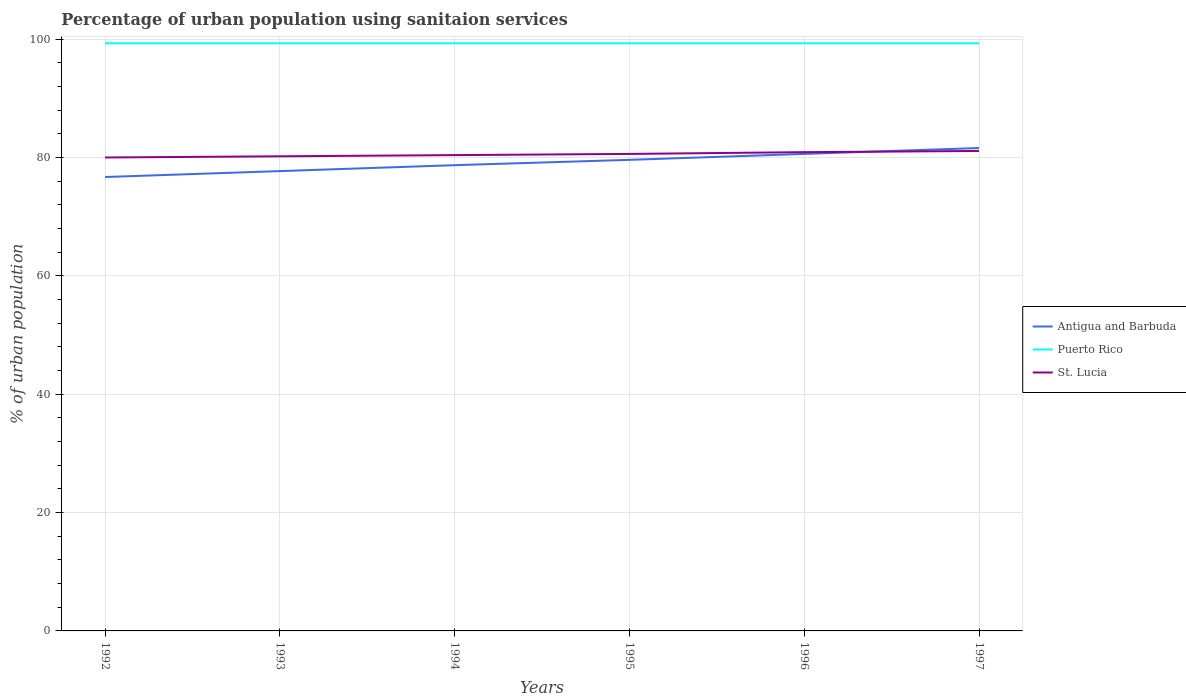Is the number of lines equal to the number of legend labels?
Keep it short and to the point. Yes. Across all years, what is the maximum percentage of urban population using sanitaion services in Puerto Rico?
Offer a very short reply. 99.3. In which year was the percentage of urban population using sanitaion services in St. Lucia maximum?
Your answer should be compact. 1992. What is the total percentage of urban population using sanitaion services in Antigua and Barbuda in the graph?
Your answer should be compact. -2.9. What is the difference between the highest and the second highest percentage of urban population using sanitaion services in St. Lucia?
Your response must be concise. 1.1. What is the difference between the highest and the lowest percentage of urban population using sanitaion services in Antigua and Barbuda?
Offer a very short reply. 3. How many lines are there?
Provide a succinct answer. 3. How many years are there in the graph?
Offer a terse response. 6. Does the graph contain any zero values?
Your response must be concise. No. Does the graph contain grids?
Offer a very short reply. Yes. How many legend labels are there?
Offer a terse response. 3. What is the title of the graph?
Your answer should be compact. Percentage of urban population using sanitaion services. What is the label or title of the Y-axis?
Your response must be concise. % of urban population. What is the % of urban population of Antigua and Barbuda in 1992?
Offer a terse response. 76.7. What is the % of urban population of Puerto Rico in 1992?
Make the answer very short. 99.3. What is the % of urban population of Antigua and Barbuda in 1993?
Your answer should be very brief. 77.7. What is the % of urban population in Puerto Rico in 1993?
Provide a short and direct response. 99.3. What is the % of urban population in St. Lucia in 1993?
Offer a terse response. 80.2. What is the % of urban population in Antigua and Barbuda in 1994?
Your response must be concise. 78.7. What is the % of urban population of Puerto Rico in 1994?
Your answer should be very brief. 99.3. What is the % of urban population of St. Lucia in 1994?
Ensure brevity in your answer.  80.4. What is the % of urban population of Antigua and Barbuda in 1995?
Offer a very short reply. 79.6. What is the % of urban population of Puerto Rico in 1995?
Make the answer very short. 99.3. What is the % of urban population in St. Lucia in 1995?
Ensure brevity in your answer.  80.6. What is the % of urban population in Antigua and Barbuda in 1996?
Your answer should be compact. 80.6. What is the % of urban population in Puerto Rico in 1996?
Provide a short and direct response. 99.3. What is the % of urban population in St. Lucia in 1996?
Provide a short and direct response. 80.9. What is the % of urban population of Antigua and Barbuda in 1997?
Offer a terse response. 81.6. What is the % of urban population in Puerto Rico in 1997?
Your answer should be very brief. 99.3. What is the % of urban population in St. Lucia in 1997?
Your answer should be compact. 81.1. Across all years, what is the maximum % of urban population in Antigua and Barbuda?
Offer a terse response. 81.6. Across all years, what is the maximum % of urban population in Puerto Rico?
Provide a succinct answer. 99.3. Across all years, what is the maximum % of urban population of St. Lucia?
Your response must be concise. 81.1. Across all years, what is the minimum % of urban population of Antigua and Barbuda?
Provide a succinct answer. 76.7. Across all years, what is the minimum % of urban population of Puerto Rico?
Your answer should be compact. 99.3. Across all years, what is the minimum % of urban population of St. Lucia?
Offer a very short reply. 80. What is the total % of urban population of Antigua and Barbuda in the graph?
Your answer should be compact. 474.9. What is the total % of urban population in Puerto Rico in the graph?
Provide a succinct answer. 595.8. What is the total % of urban population in St. Lucia in the graph?
Make the answer very short. 483.2. What is the difference between the % of urban population of Antigua and Barbuda in 1992 and that in 1993?
Your response must be concise. -1. What is the difference between the % of urban population of Puerto Rico in 1992 and that in 1993?
Offer a very short reply. 0. What is the difference between the % of urban population of St. Lucia in 1992 and that in 1993?
Make the answer very short. -0.2. What is the difference between the % of urban population in Puerto Rico in 1992 and that in 1994?
Make the answer very short. 0. What is the difference between the % of urban population of Antigua and Barbuda in 1992 and that in 1995?
Keep it short and to the point. -2.9. What is the difference between the % of urban population in Puerto Rico in 1992 and that in 1995?
Provide a succinct answer. 0. What is the difference between the % of urban population of Puerto Rico in 1992 and that in 1996?
Make the answer very short. 0. What is the difference between the % of urban population in St. Lucia in 1992 and that in 1996?
Your answer should be very brief. -0.9. What is the difference between the % of urban population of Antigua and Barbuda in 1992 and that in 1997?
Give a very brief answer. -4.9. What is the difference between the % of urban population in Puerto Rico in 1992 and that in 1997?
Provide a short and direct response. 0. What is the difference between the % of urban population in Antigua and Barbuda in 1993 and that in 1994?
Provide a short and direct response. -1. What is the difference between the % of urban population of St. Lucia in 1993 and that in 1996?
Your response must be concise. -0.7. What is the difference between the % of urban population in Puerto Rico in 1993 and that in 1997?
Keep it short and to the point. 0. What is the difference between the % of urban population in St. Lucia in 1993 and that in 1997?
Provide a succinct answer. -0.9. What is the difference between the % of urban population of Antigua and Barbuda in 1994 and that in 1995?
Your response must be concise. -0.9. What is the difference between the % of urban population of St. Lucia in 1994 and that in 1995?
Your response must be concise. -0.2. What is the difference between the % of urban population of Puerto Rico in 1994 and that in 1996?
Give a very brief answer. 0. What is the difference between the % of urban population in Antigua and Barbuda in 1995 and that in 1996?
Give a very brief answer. -1. What is the difference between the % of urban population in St. Lucia in 1995 and that in 1996?
Offer a very short reply. -0.3. What is the difference between the % of urban population in Antigua and Barbuda in 1995 and that in 1997?
Offer a terse response. -2. What is the difference between the % of urban population in Puerto Rico in 1995 and that in 1997?
Provide a succinct answer. 0. What is the difference between the % of urban population of St. Lucia in 1995 and that in 1997?
Ensure brevity in your answer.  -0.5. What is the difference between the % of urban population in Antigua and Barbuda in 1992 and the % of urban population in Puerto Rico in 1993?
Offer a very short reply. -22.6. What is the difference between the % of urban population of Puerto Rico in 1992 and the % of urban population of St. Lucia in 1993?
Provide a succinct answer. 19.1. What is the difference between the % of urban population of Antigua and Barbuda in 1992 and the % of urban population of Puerto Rico in 1994?
Provide a short and direct response. -22.6. What is the difference between the % of urban population in Antigua and Barbuda in 1992 and the % of urban population in St. Lucia in 1994?
Ensure brevity in your answer.  -3.7. What is the difference between the % of urban population of Antigua and Barbuda in 1992 and the % of urban population of Puerto Rico in 1995?
Make the answer very short. -22.6. What is the difference between the % of urban population in Antigua and Barbuda in 1992 and the % of urban population in St. Lucia in 1995?
Your answer should be very brief. -3.9. What is the difference between the % of urban population of Puerto Rico in 1992 and the % of urban population of St. Lucia in 1995?
Your response must be concise. 18.7. What is the difference between the % of urban population of Antigua and Barbuda in 1992 and the % of urban population of Puerto Rico in 1996?
Ensure brevity in your answer.  -22.6. What is the difference between the % of urban population in Antigua and Barbuda in 1992 and the % of urban population in Puerto Rico in 1997?
Your response must be concise. -22.6. What is the difference between the % of urban population in Antigua and Barbuda in 1993 and the % of urban population in Puerto Rico in 1994?
Offer a terse response. -21.6. What is the difference between the % of urban population of Antigua and Barbuda in 1993 and the % of urban population of St. Lucia in 1994?
Provide a short and direct response. -2.7. What is the difference between the % of urban population in Puerto Rico in 1993 and the % of urban population in St. Lucia in 1994?
Your response must be concise. 18.9. What is the difference between the % of urban population of Antigua and Barbuda in 1993 and the % of urban population of Puerto Rico in 1995?
Provide a succinct answer. -21.6. What is the difference between the % of urban population of Antigua and Barbuda in 1993 and the % of urban population of St. Lucia in 1995?
Keep it short and to the point. -2.9. What is the difference between the % of urban population of Antigua and Barbuda in 1993 and the % of urban population of Puerto Rico in 1996?
Provide a short and direct response. -21.6. What is the difference between the % of urban population of Antigua and Barbuda in 1993 and the % of urban population of St. Lucia in 1996?
Provide a succinct answer. -3.2. What is the difference between the % of urban population in Puerto Rico in 1993 and the % of urban population in St. Lucia in 1996?
Keep it short and to the point. 18.4. What is the difference between the % of urban population of Antigua and Barbuda in 1993 and the % of urban population of Puerto Rico in 1997?
Your answer should be compact. -21.6. What is the difference between the % of urban population in Antigua and Barbuda in 1993 and the % of urban population in St. Lucia in 1997?
Make the answer very short. -3.4. What is the difference between the % of urban population in Antigua and Barbuda in 1994 and the % of urban population in Puerto Rico in 1995?
Provide a succinct answer. -20.6. What is the difference between the % of urban population in Antigua and Barbuda in 1994 and the % of urban population in St. Lucia in 1995?
Keep it short and to the point. -1.9. What is the difference between the % of urban population in Antigua and Barbuda in 1994 and the % of urban population in Puerto Rico in 1996?
Your answer should be compact. -20.6. What is the difference between the % of urban population in Antigua and Barbuda in 1994 and the % of urban population in St. Lucia in 1996?
Give a very brief answer. -2.2. What is the difference between the % of urban population in Antigua and Barbuda in 1994 and the % of urban population in Puerto Rico in 1997?
Your answer should be compact. -20.6. What is the difference between the % of urban population in Antigua and Barbuda in 1995 and the % of urban population in Puerto Rico in 1996?
Provide a short and direct response. -19.7. What is the difference between the % of urban population of Puerto Rico in 1995 and the % of urban population of St. Lucia in 1996?
Offer a very short reply. 18.4. What is the difference between the % of urban population of Antigua and Barbuda in 1995 and the % of urban population of Puerto Rico in 1997?
Offer a very short reply. -19.7. What is the difference between the % of urban population in Puerto Rico in 1995 and the % of urban population in St. Lucia in 1997?
Your answer should be very brief. 18.2. What is the difference between the % of urban population of Antigua and Barbuda in 1996 and the % of urban population of Puerto Rico in 1997?
Keep it short and to the point. -18.7. What is the difference between the % of urban population in Puerto Rico in 1996 and the % of urban population in St. Lucia in 1997?
Provide a short and direct response. 18.2. What is the average % of urban population of Antigua and Barbuda per year?
Your response must be concise. 79.15. What is the average % of urban population in Puerto Rico per year?
Your answer should be compact. 99.3. What is the average % of urban population in St. Lucia per year?
Offer a very short reply. 80.53. In the year 1992, what is the difference between the % of urban population of Antigua and Barbuda and % of urban population of Puerto Rico?
Offer a terse response. -22.6. In the year 1992, what is the difference between the % of urban population of Antigua and Barbuda and % of urban population of St. Lucia?
Give a very brief answer. -3.3. In the year 1992, what is the difference between the % of urban population in Puerto Rico and % of urban population in St. Lucia?
Provide a succinct answer. 19.3. In the year 1993, what is the difference between the % of urban population in Antigua and Barbuda and % of urban population in Puerto Rico?
Ensure brevity in your answer.  -21.6. In the year 1993, what is the difference between the % of urban population in Puerto Rico and % of urban population in St. Lucia?
Provide a short and direct response. 19.1. In the year 1994, what is the difference between the % of urban population of Antigua and Barbuda and % of urban population of Puerto Rico?
Keep it short and to the point. -20.6. In the year 1995, what is the difference between the % of urban population of Antigua and Barbuda and % of urban population of Puerto Rico?
Offer a terse response. -19.7. In the year 1995, what is the difference between the % of urban population of Antigua and Barbuda and % of urban population of St. Lucia?
Ensure brevity in your answer.  -1. In the year 1996, what is the difference between the % of urban population of Antigua and Barbuda and % of urban population of Puerto Rico?
Your answer should be very brief. -18.7. In the year 1996, what is the difference between the % of urban population in Antigua and Barbuda and % of urban population in St. Lucia?
Provide a short and direct response. -0.3. In the year 1996, what is the difference between the % of urban population of Puerto Rico and % of urban population of St. Lucia?
Make the answer very short. 18.4. In the year 1997, what is the difference between the % of urban population in Antigua and Barbuda and % of urban population in Puerto Rico?
Your answer should be very brief. -17.7. In the year 1997, what is the difference between the % of urban population of Antigua and Barbuda and % of urban population of St. Lucia?
Offer a terse response. 0.5. In the year 1997, what is the difference between the % of urban population of Puerto Rico and % of urban population of St. Lucia?
Make the answer very short. 18.2. What is the ratio of the % of urban population in Antigua and Barbuda in 1992 to that in 1993?
Offer a very short reply. 0.99. What is the ratio of the % of urban population of St. Lucia in 1992 to that in 1993?
Give a very brief answer. 1. What is the ratio of the % of urban population of Antigua and Barbuda in 1992 to that in 1994?
Offer a terse response. 0.97. What is the ratio of the % of urban population of Puerto Rico in 1992 to that in 1994?
Provide a short and direct response. 1. What is the ratio of the % of urban population in St. Lucia in 1992 to that in 1994?
Your answer should be compact. 0.99. What is the ratio of the % of urban population in Antigua and Barbuda in 1992 to that in 1995?
Your answer should be compact. 0.96. What is the ratio of the % of urban population in Puerto Rico in 1992 to that in 1995?
Make the answer very short. 1. What is the ratio of the % of urban population in Antigua and Barbuda in 1992 to that in 1996?
Keep it short and to the point. 0.95. What is the ratio of the % of urban population in St. Lucia in 1992 to that in 1996?
Make the answer very short. 0.99. What is the ratio of the % of urban population in Antigua and Barbuda in 1992 to that in 1997?
Ensure brevity in your answer.  0.94. What is the ratio of the % of urban population in St. Lucia in 1992 to that in 1997?
Provide a succinct answer. 0.99. What is the ratio of the % of urban population in Antigua and Barbuda in 1993 to that in 1994?
Provide a short and direct response. 0.99. What is the ratio of the % of urban population of Puerto Rico in 1993 to that in 1994?
Your answer should be very brief. 1. What is the ratio of the % of urban population of Antigua and Barbuda in 1993 to that in 1995?
Your response must be concise. 0.98. What is the ratio of the % of urban population in St. Lucia in 1993 to that in 1995?
Keep it short and to the point. 0.99. What is the ratio of the % of urban population of Puerto Rico in 1993 to that in 1996?
Your response must be concise. 1. What is the ratio of the % of urban population in Antigua and Barbuda in 1993 to that in 1997?
Give a very brief answer. 0.95. What is the ratio of the % of urban population of Puerto Rico in 1993 to that in 1997?
Offer a terse response. 1. What is the ratio of the % of urban population of St. Lucia in 1993 to that in 1997?
Provide a succinct answer. 0.99. What is the ratio of the % of urban population in Antigua and Barbuda in 1994 to that in 1995?
Your answer should be compact. 0.99. What is the ratio of the % of urban population of Antigua and Barbuda in 1994 to that in 1996?
Your answer should be compact. 0.98. What is the ratio of the % of urban population of Antigua and Barbuda in 1994 to that in 1997?
Provide a succinct answer. 0.96. What is the ratio of the % of urban population of Antigua and Barbuda in 1995 to that in 1996?
Provide a short and direct response. 0.99. What is the ratio of the % of urban population in Puerto Rico in 1995 to that in 1996?
Give a very brief answer. 1. What is the ratio of the % of urban population of St. Lucia in 1995 to that in 1996?
Offer a terse response. 1. What is the ratio of the % of urban population of Antigua and Barbuda in 1995 to that in 1997?
Provide a succinct answer. 0.98. What is the ratio of the % of urban population in Puerto Rico in 1995 to that in 1997?
Keep it short and to the point. 1. What is the ratio of the % of urban population of St. Lucia in 1995 to that in 1997?
Your answer should be compact. 0.99. What is the ratio of the % of urban population in Puerto Rico in 1996 to that in 1997?
Your answer should be compact. 1. What is the ratio of the % of urban population of St. Lucia in 1996 to that in 1997?
Make the answer very short. 1. What is the difference between the highest and the second highest % of urban population of Puerto Rico?
Keep it short and to the point. 0. 